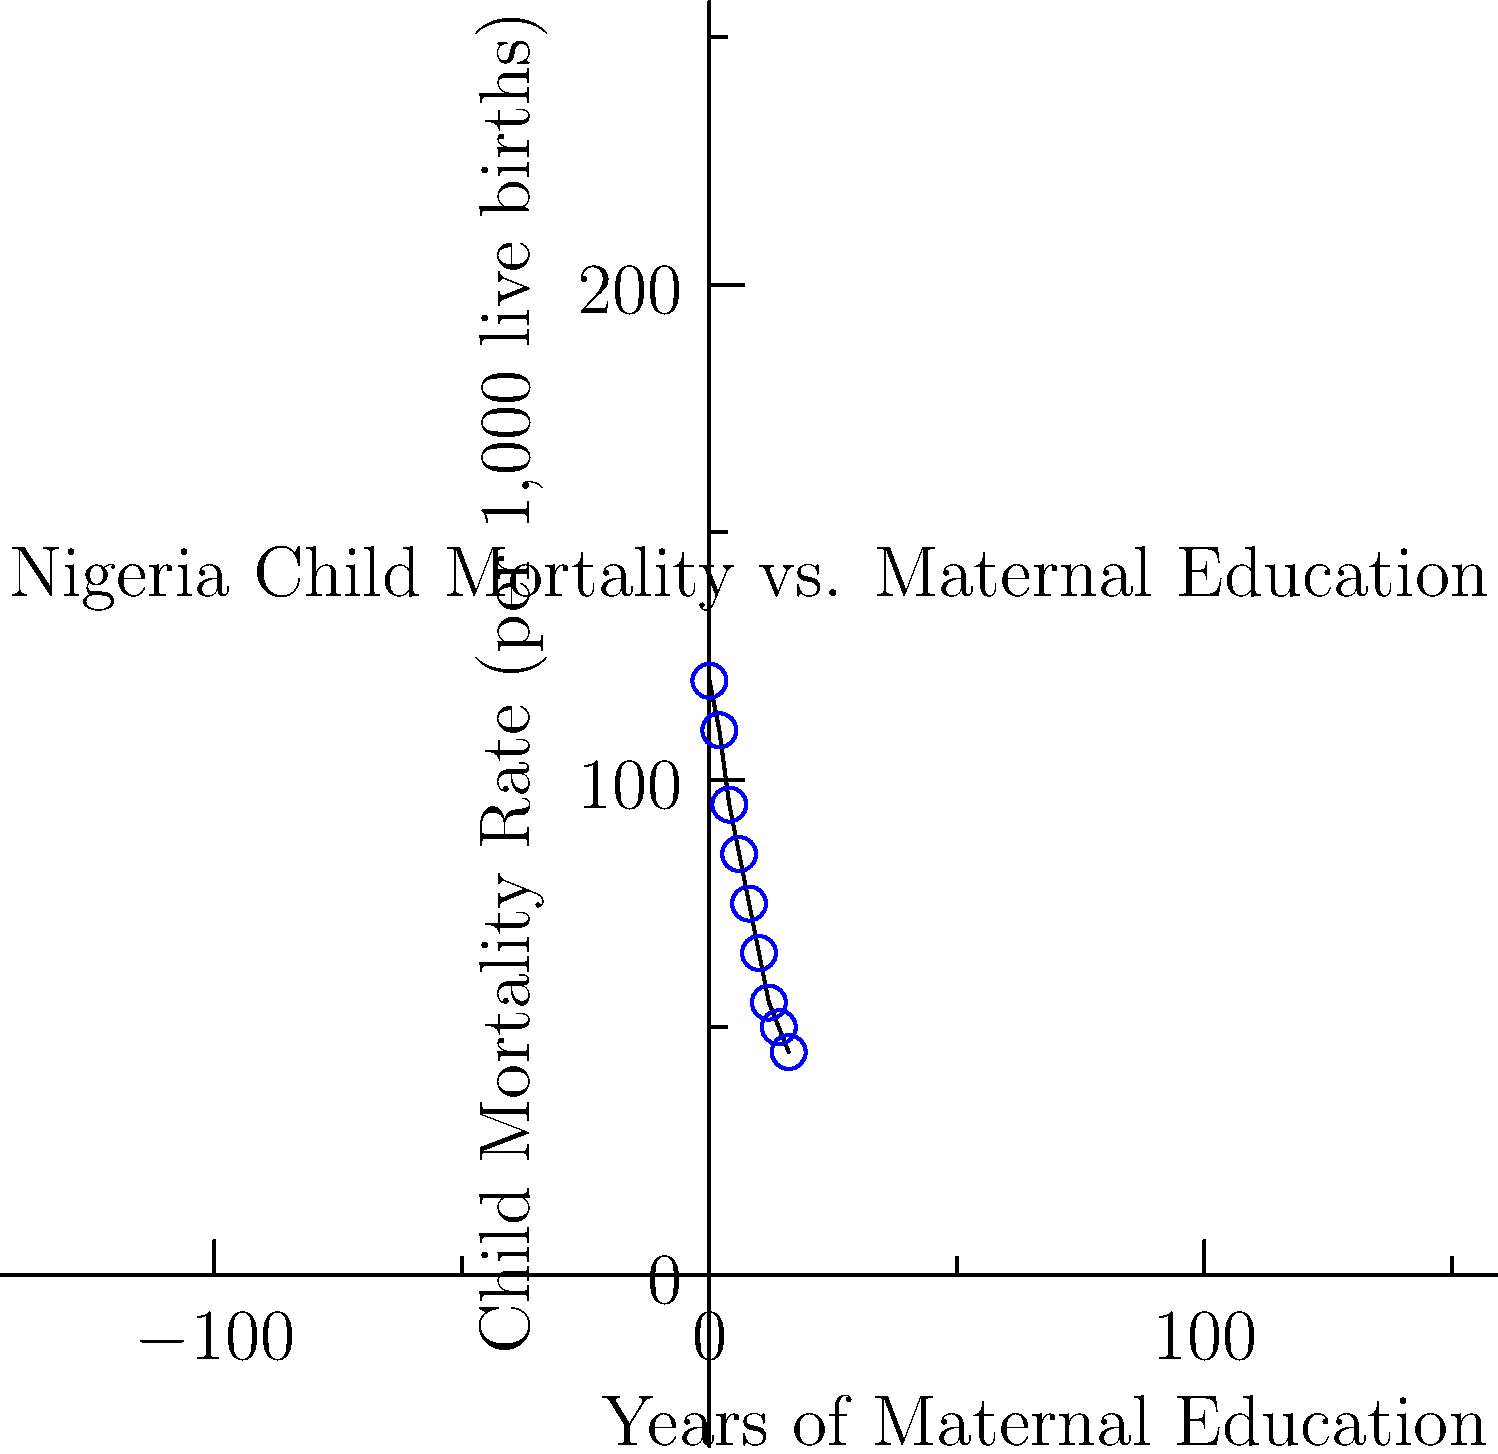Based on the scatter plot showing the relationship between maternal education levels and child mortality rates in Nigeria, estimate the reduction in child mortality rate (per 1,000 live births) for every two years increase in maternal education. What does this suggest about the potential impact of improving maternal education on child survival rates? To answer this question, we need to follow these steps:

1. Observe the overall trend in the scatter plot: As maternal education increases, child mortality rates decrease.

2. Calculate the change in child mortality rate for each 2-year increment in maternal education:
   - 0 to 2 years: 120 - 110 = 10
   - 2 to 4 years: 110 - 95 = 15
   - 4 to 6 years: 95 - 85 = 10
   - 6 to 8 years: 85 - 75 = 10
   - 8 to 10 years: 75 - 65 = 10
   - 10 to 12 years: 65 - 55 = 10
   - 12 to 14 years: 55 - 50 = 5
   - 14 to 16 years: 50 - 45 = 5

3. Calculate the average reduction:
   $\frac{10 + 15 + 10 + 10 + 10 + 10 + 5 + 5}{8} = \frac{75}{8} = 9.375$

4. Round to the nearest whole number: 9 deaths per 1,000 live births

5. Interpret the result: For every two years increase in maternal education, there is an estimated reduction of 9 deaths per 1,000 live births in child mortality rate.

This suggests that improving maternal education could have a significant positive impact on child survival rates in Nigeria. As maternal education levels increase, mothers are likely to have better knowledge of child health, nutrition, and care practices, leading to improved child survival outcomes.
Answer: 9 deaths per 1,000 live births reduction; significant positive impact on child survival 